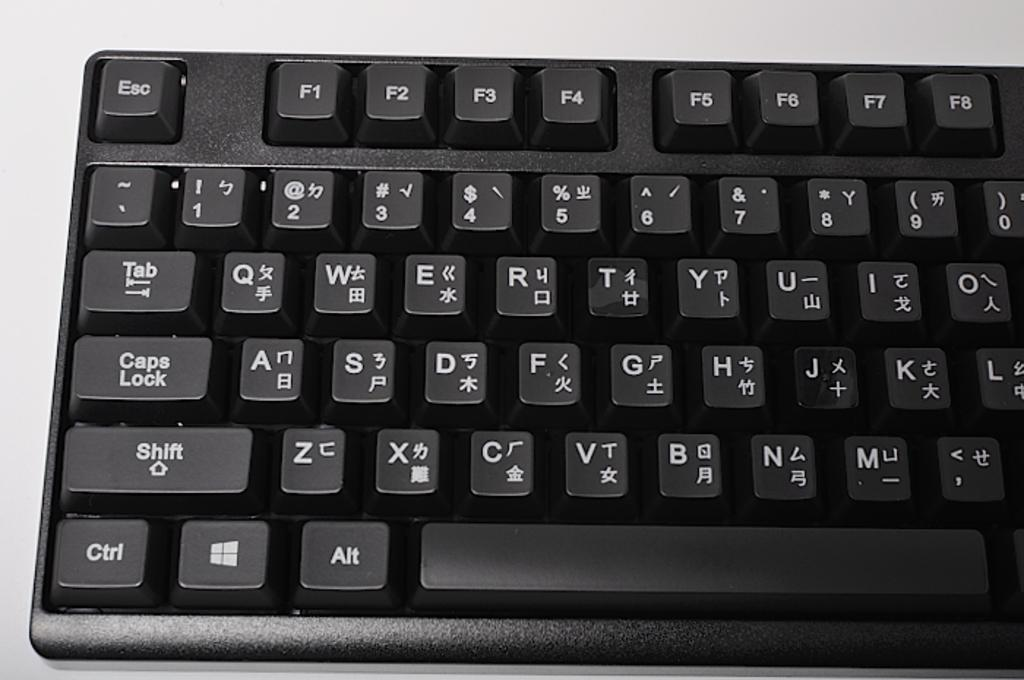<image>
Provide a brief description of the given image. A keyboard that uses the English alphabet and Qwerty layout. 